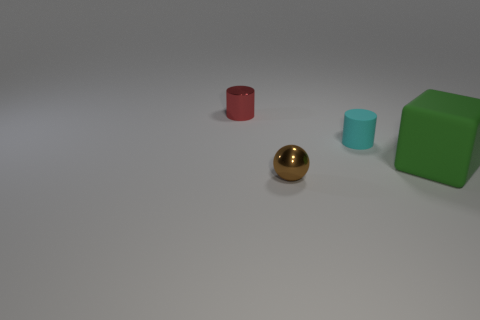Subtract all red balls. Subtract all blue cylinders. How many balls are left? 1 Add 3 large gray cylinders. How many objects exist? 7 Subtract all balls. How many objects are left? 3 Add 2 small matte things. How many small matte things are left? 3 Add 3 cyan matte cylinders. How many cyan matte cylinders exist? 4 Subtract 1 cyan cylinders. How many objects are left? 3 Subtract all cyan rubber spheres. Subtract all tiny cyan cylinders. How many objects are left? 3 